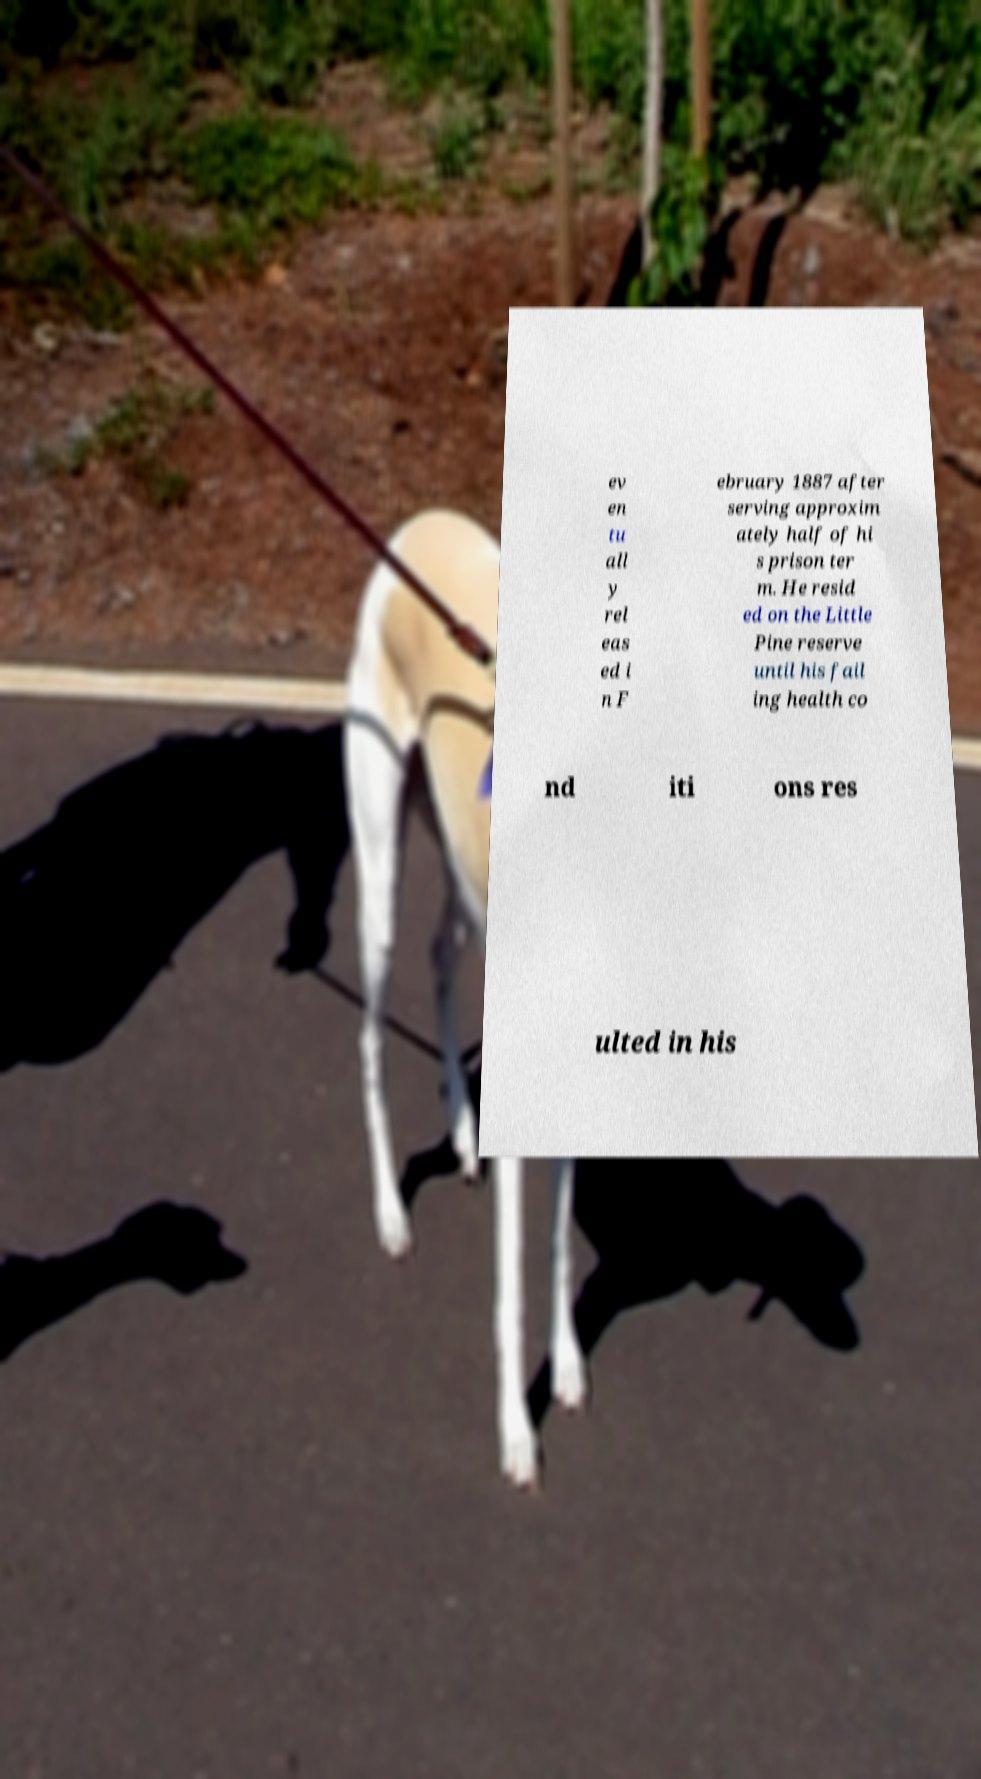Can you accurately transcribe the text from the provided image for me? ev en tu all y rel eas ed i n F ebruary 1887 after serving approxim ately half of hi s prison ter m. He resid ed on the Little Pine reserve until his fail ing health co nd iti ons res ulted in his 